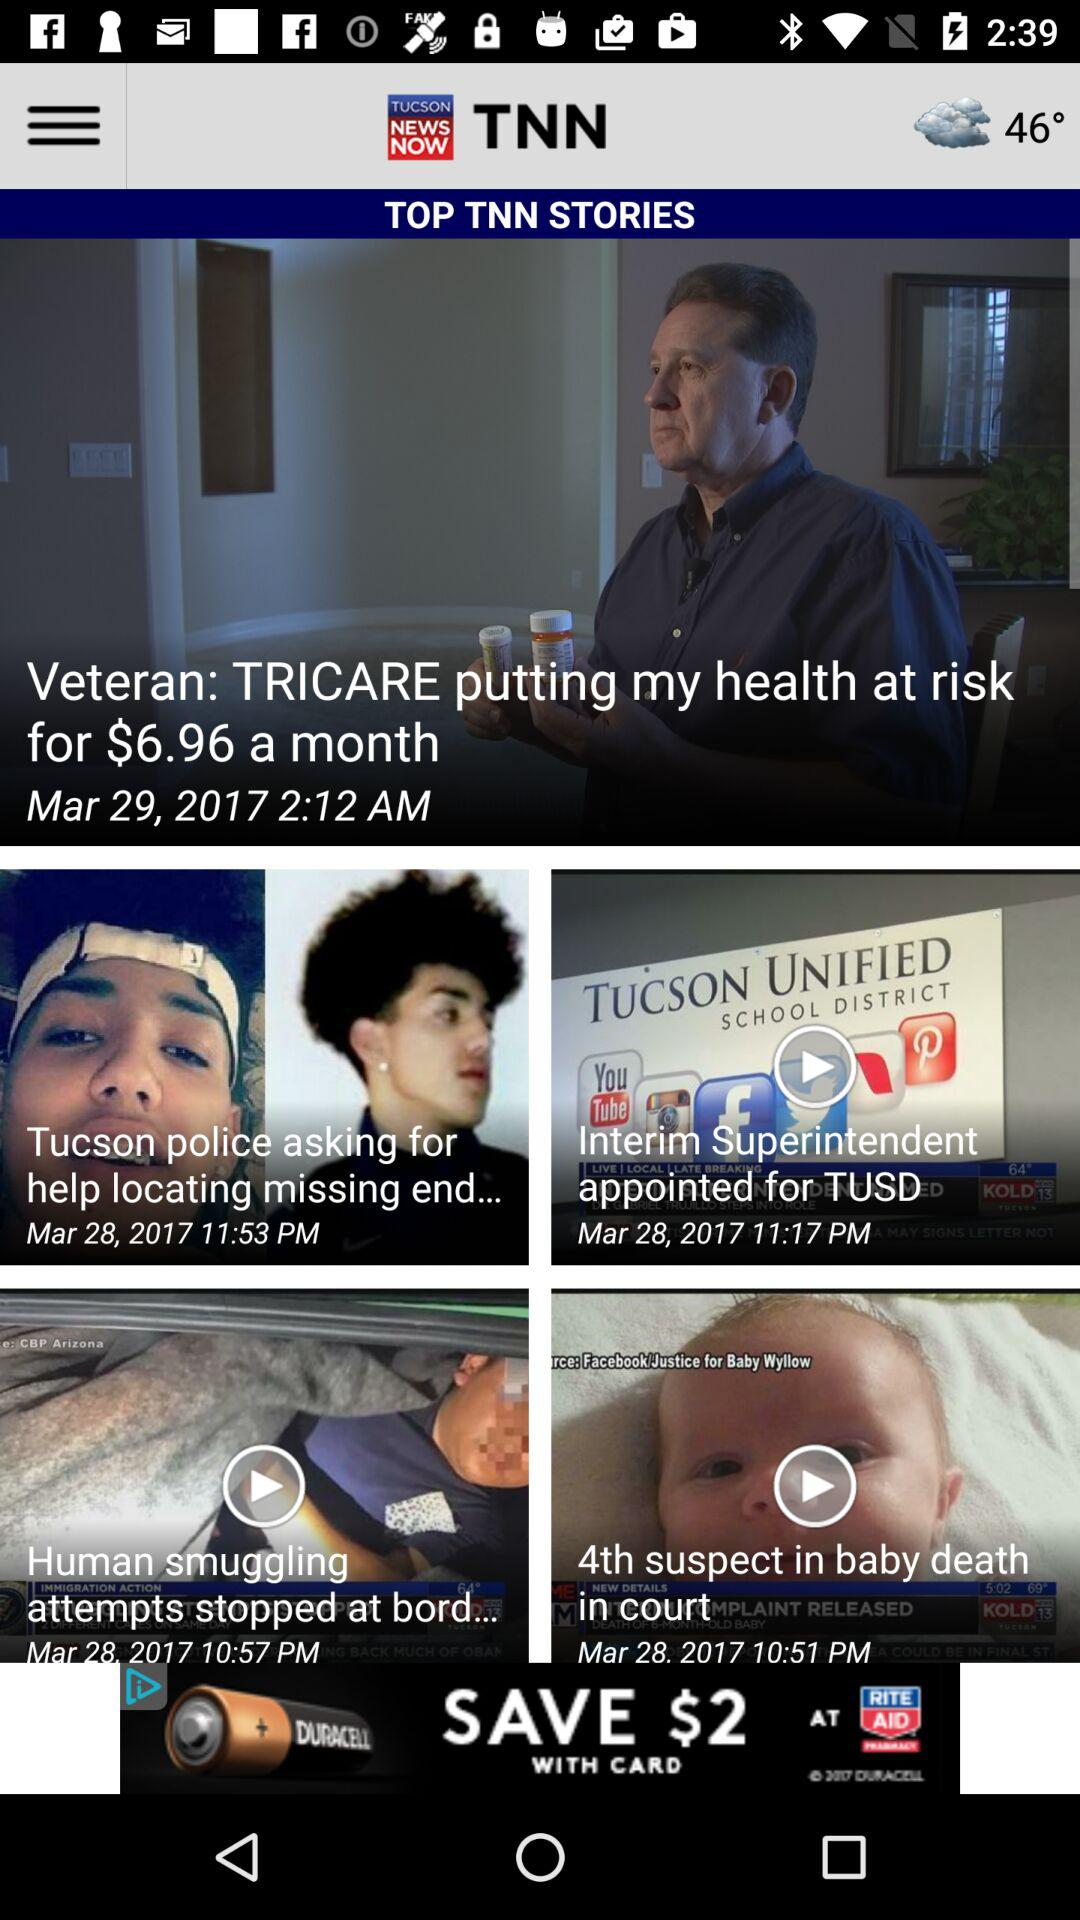What is the temperature shown on the screen? The shown temperature is 46°. 